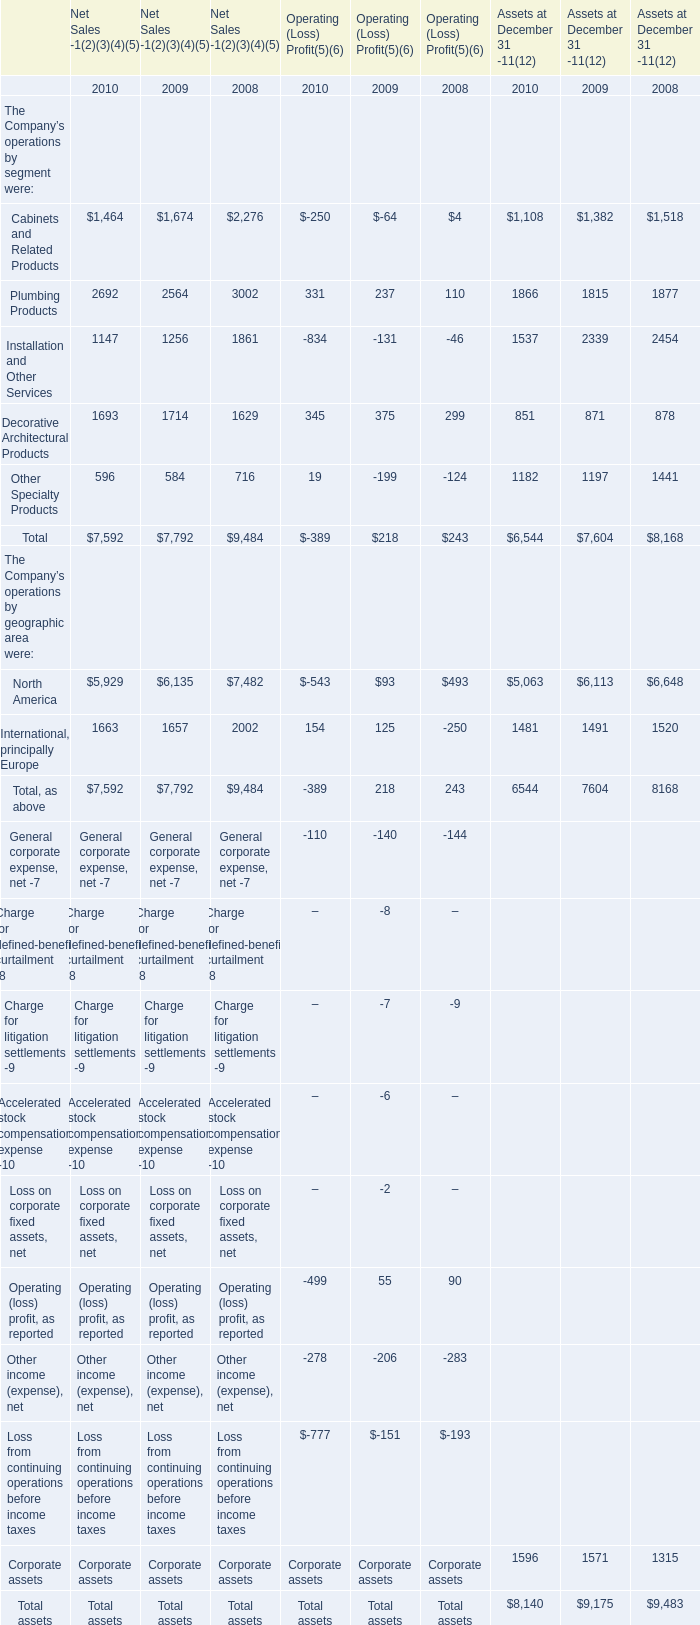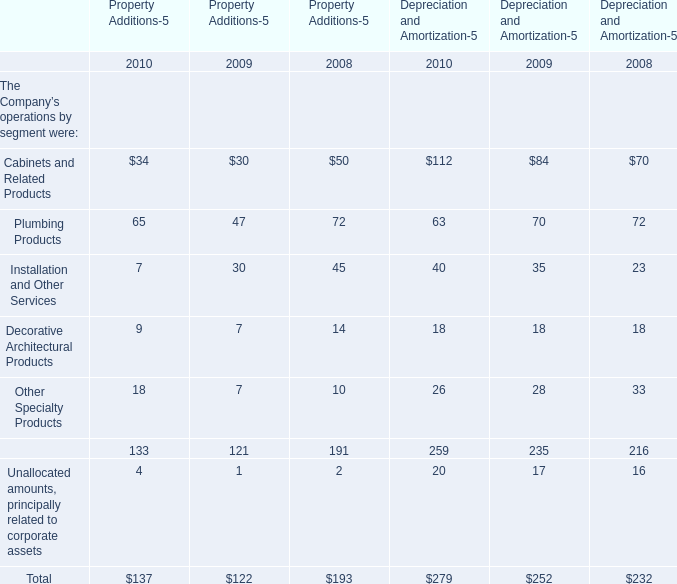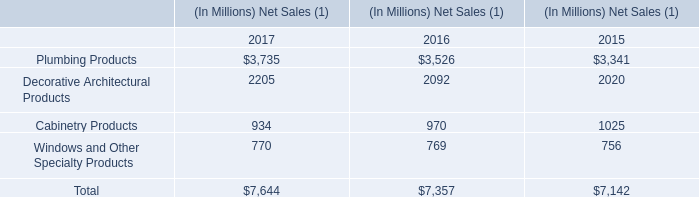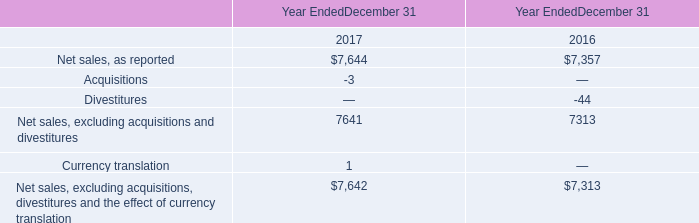How many Operating (Loss) Profit(5)(6) exceed the average of Operating (Loss) Profit(5)(6) in 2009? 
Answer: 2. 